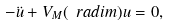Convert formula to latex. <formula><loc_0><loc_0><loc_500><loc_500>- \ddot { u } + V _ { M } ( \ r a d i m ) u = 0 ,</formula> 